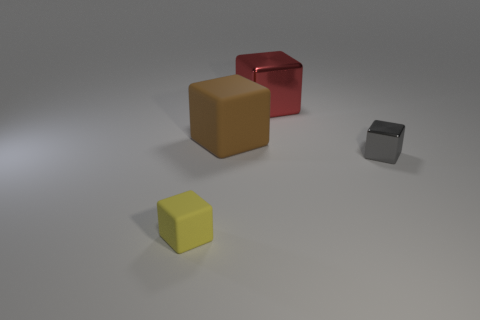What is the color of the rubber thing that is behind the small yellow cube?
Your answer should be very brief. Brown. How many objects are cubes that are left of the red object or big red objects?
Give a very brief answer. 3. There is a metallic cube that is the same size as the brown thing; what color is it?
Offer a very short reply. Red. Are there more big metallic blocks behind the big brown thing than yellow balls?
Keep it short and to the point. Yes. There is a block that is to the left of the big red metallic thing and right of the yellow matte cube; what material is it made of?
Make the answer very short. Rubber. What number of other things are the same size as the brown matte object?
Offer a very short reply. 1. There is a large block that is in front of the large thing behind the brown cube; are there any metallic blocks behind it?
Offer a very short reply. Yes. Do the object that is right of the red cube and the brown cube have the same material?
Offer a terse response. No. What color is the other large matte thing that is the same shape as the yellow object?
Your answer should be very brief. Brown. Are there the same number of things right of the red metal object and yellow rubber blocks?
Provide a succinct answer. Yes. 